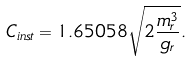<formula> <loc_0><loc_0><loc_500><loc_500>C _ { i n s t } = 1 . 6 5 0 5 8 \sqrt { 2 \frac { m _ { r } ^ { 3 } } { g _ { r } } } .</formula> 